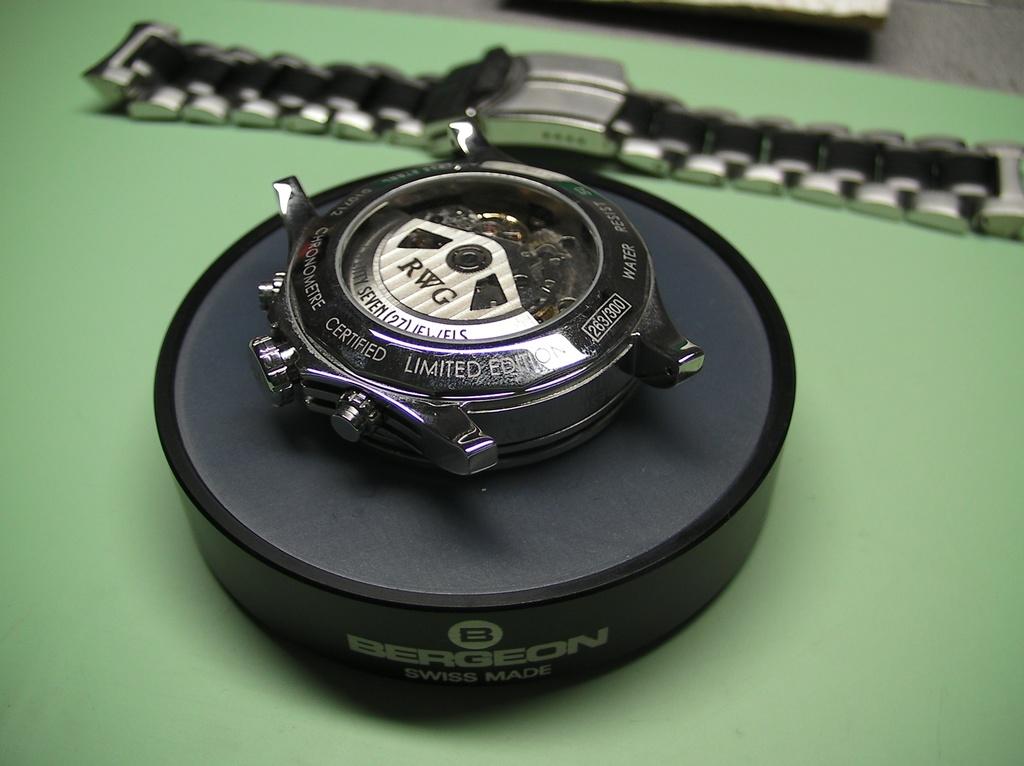What is the brand name?
Make the answer very short. Bergeon. What type of edition is shown?
Provide a succinct answer. Limited. 